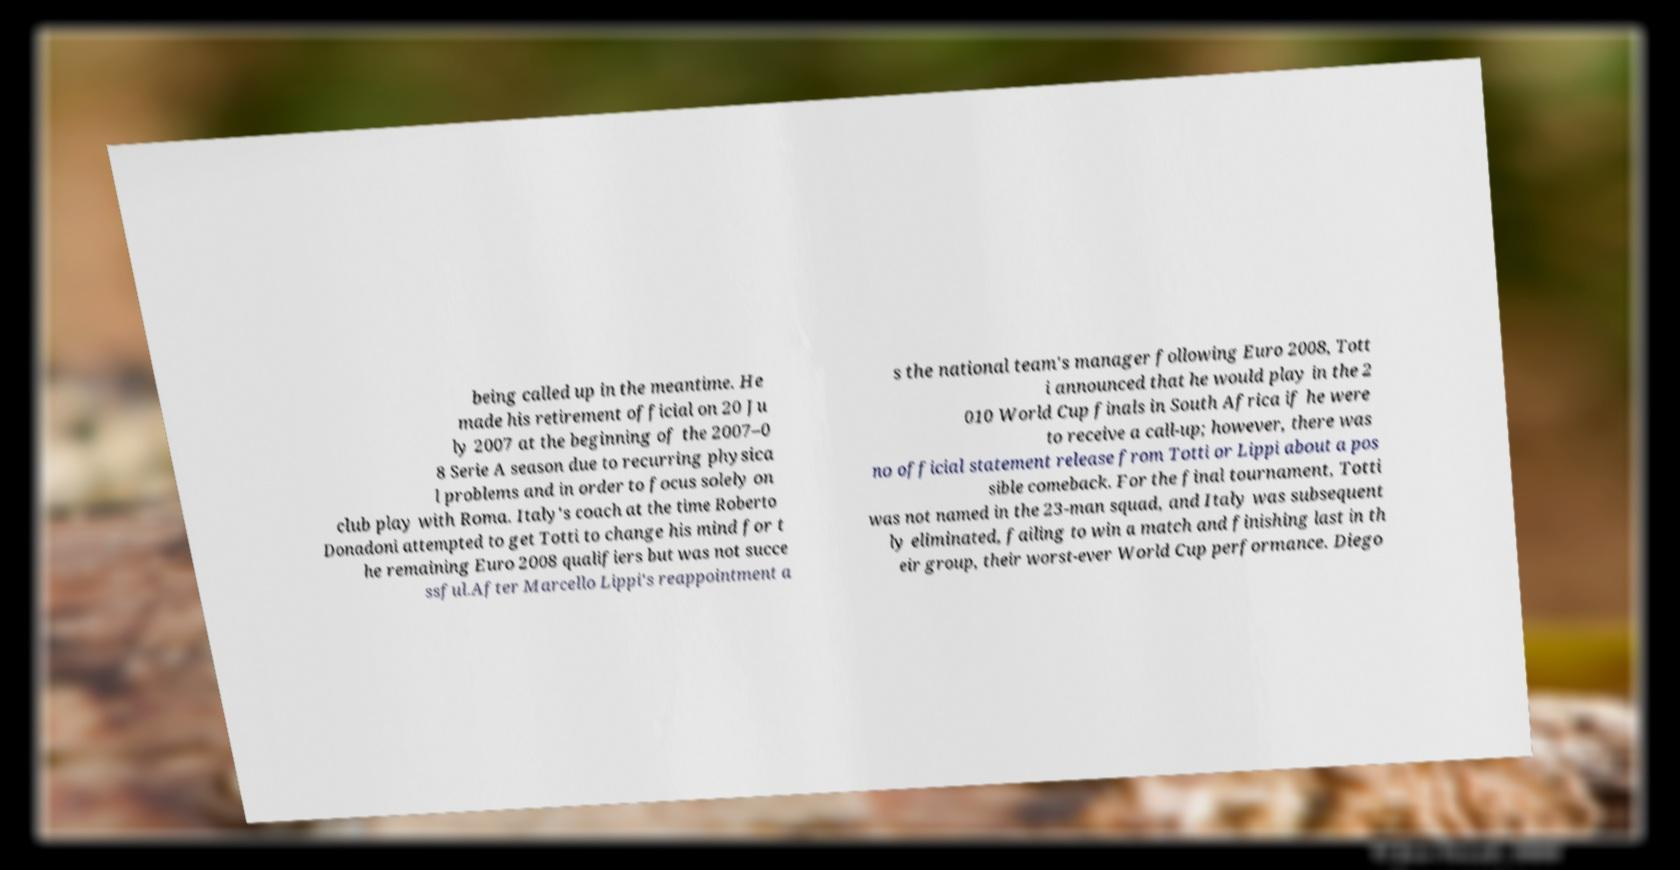I need the written content from this picture converted into text. Can you do that? being called up in the meantime. He made his retirement official on 20 Ju ly 2007 at the beginning of the 2007–0 8 Serie A season due to recurring physica l problems and in order to focus solely on club play with Roma. Italy's coach at the time Roberto Donadoni attempted to get Totti to change his mind for t he remaining Euro 2008 qualifiers but was not succe ssful.After Marcello Lippi's reappointment a s the national team's manager following Euro 2008, Tott i announced that he would play in the 2 010 World Cup finals in South Africa if he were to receive a call-up; however, there was no official statement release from Totti or Lippi about a pos sible comeback. For the final tournament, Totti was not named in the 23-man squad, and Italy was subsequent ly eliminated, failing to win a match and finishing last in th eir group, their worst-ever World Cup performance. Diego 